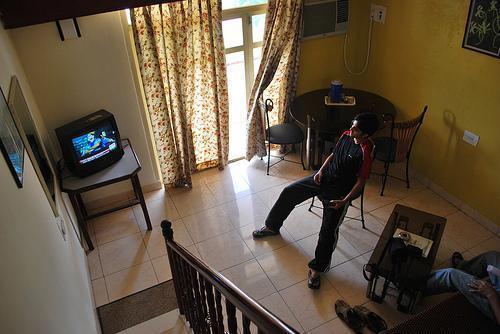How many people are in the image?
Give a very brief answer. 2. 